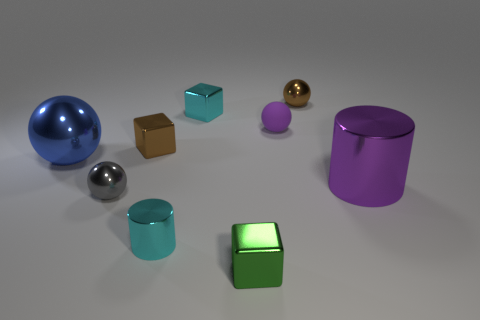How many objects are in the image and can you describe them? There are eight objects in the image, including spheres, cubes, and cylindrical shapes, each with a distinct color ranging from blue, brown, pink, purple, and varying shades of gray and green. 